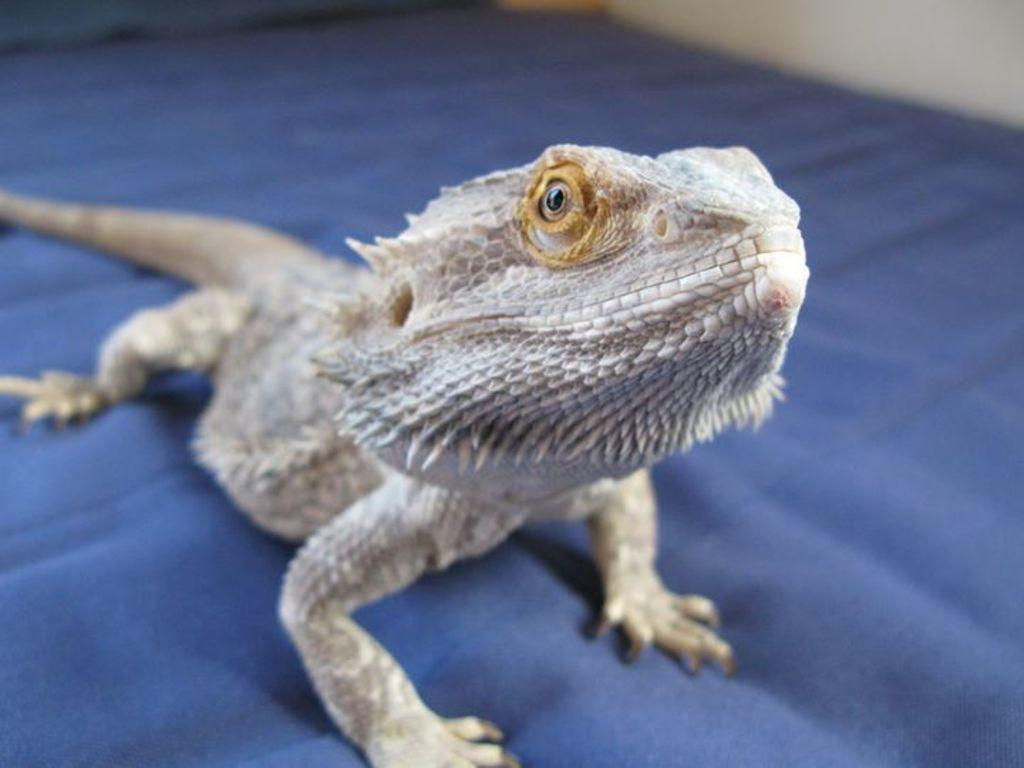What type of animal is in the image? There is a chameleon in the image. What is the chameleon resting on? The chameleon is on a carpet. What color is the sweater the chameleon is wearing in the image? There is no sweater present in the image, and chameleons do not wear clothing. 